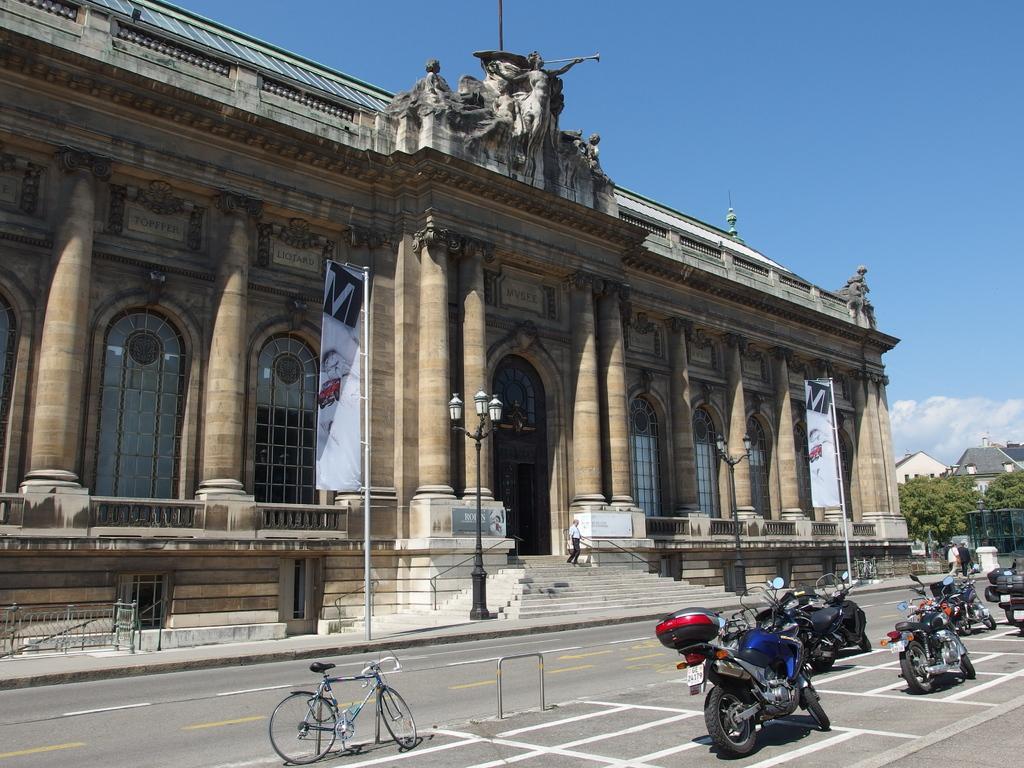How would you summarize this image in a sentence or two? In this image there is a road. On the road there are many motorcycles. Near to that there is a cycle. In the back there is a building with pillars and windows. There is a pole with flags. There are steps. On the building there are sculptures. In the background there is sky. 